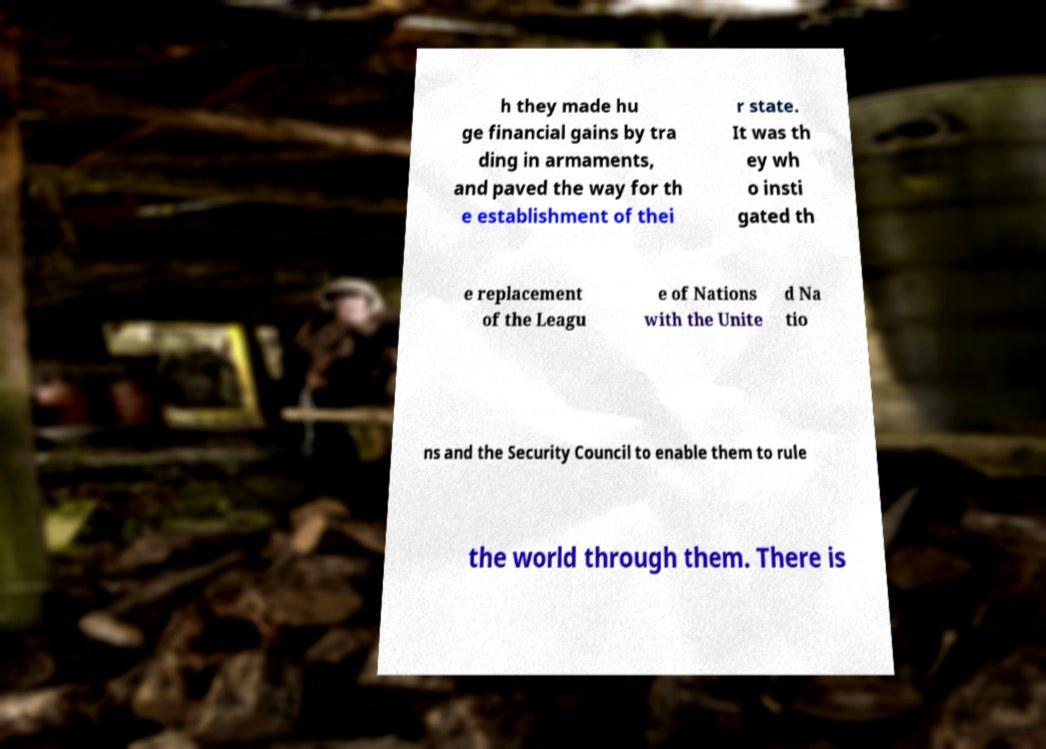I need the written content from this picture converted into text. Can you do that? h they made hu ge financial gains by tra ding in armaments, and paved the way for th e establishment of thei r state. It was th ey wh o insti gated th e replacement of the Leagu e of Nations with the Unite d Na tio ns and the Security Council to enable them to rule the world through them. There is 